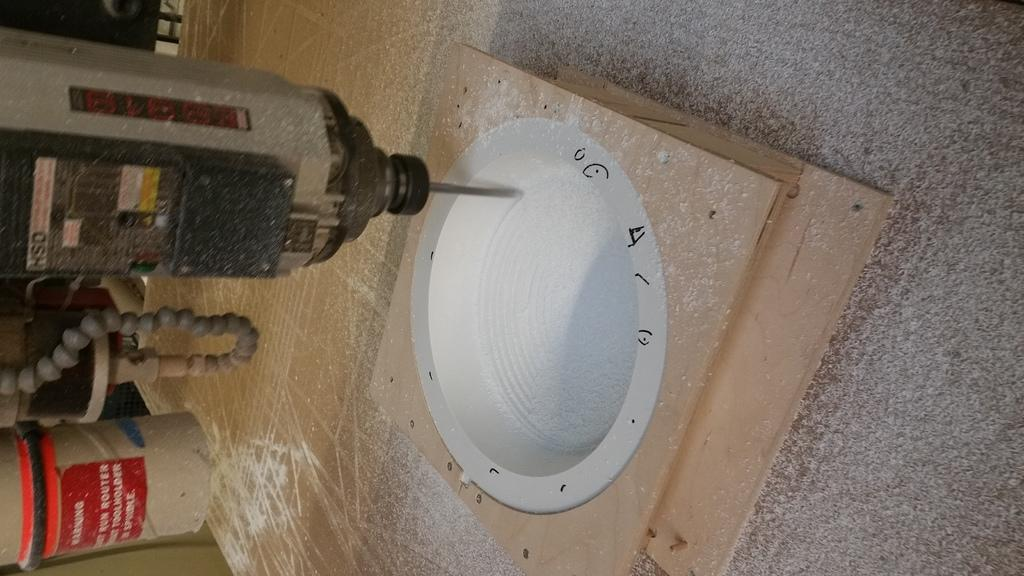What is the main object in the image? There is a drilling tool in the image. Are there any other objects present on the platform in the image? Yes, there are other objects on the platform in the image. What type of cream is being used by the person sneezing in the image? There is no person sneezing in the image, and therefore no cream can be associated with the image. 